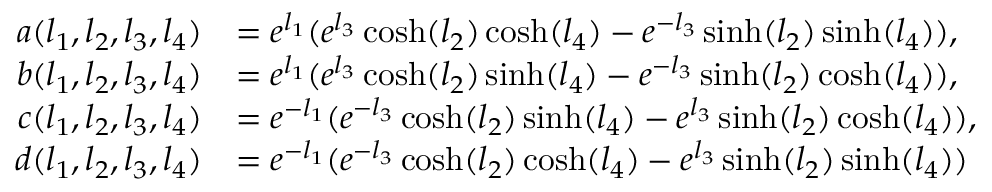<formula> <loc_0><loc_0><loc_500><loc_500>\begin{array} { r l } { a ( l _ { 1 } , l _ { 2 } , l _ { 3 } , l _ { 4 } ) } & { = e ^ { l _ { 1 } } ( e ^ { l _ { 3 } } \cosh ( { l _ { 2 } } ) \cosh ( { l _ { 4 } } ) - e ^ { - l _ { 3 } } \sinh ( { l _ { 2 } } ) \sinh ( { l _ { 4 } } ) ) , } \\ { b ( l _ { 1 } , l _ { 2 } , l _ { 3 } , l _ { 4 } ) } & { = e ^ { l _ { 1 } } ( e ^ { l _ { 3 } } \cosh ( { l _ { 2 } } ) \sinh ( { l _ { 4 } } ) - e ^ { - l _ { 3 } } \sinh ( { l _ { 2 } } ) \cosh ( { l _ { 4 } } ) ) , } \\ { c ( l _ { 1 } , l _ { 2 } , l _ { 3 } , l _ { 4 } ) } & { = e ^ { - l _ { 1 } } ( e ^ { - l _ { 3 } } \cosh ( { l _ { 2 } } ) \sinh ( { l _ { 4 } } ) - e ^ { l _ { 3 } } \sinh ( { l _ { 2 } } ) \cosh ( { l _ { 4 } } ) ) , } \\ { d ( l _ { 1 } , l _ { 2 } , l _ { 3 } , l _ { 4 } ) } & { = e ^ { - l _ { 1 } } ( e ^ { - l _ { 3 } } \cosh ( { l _ { 2 } } ) \cosh ( { l _ { 4 } } ) - e ^ { l _ { 3 } } \sinh ( { l _ { 2 } } ) \sinh ( { l _ { 4 } } ) ) } \end{array}</formula> 